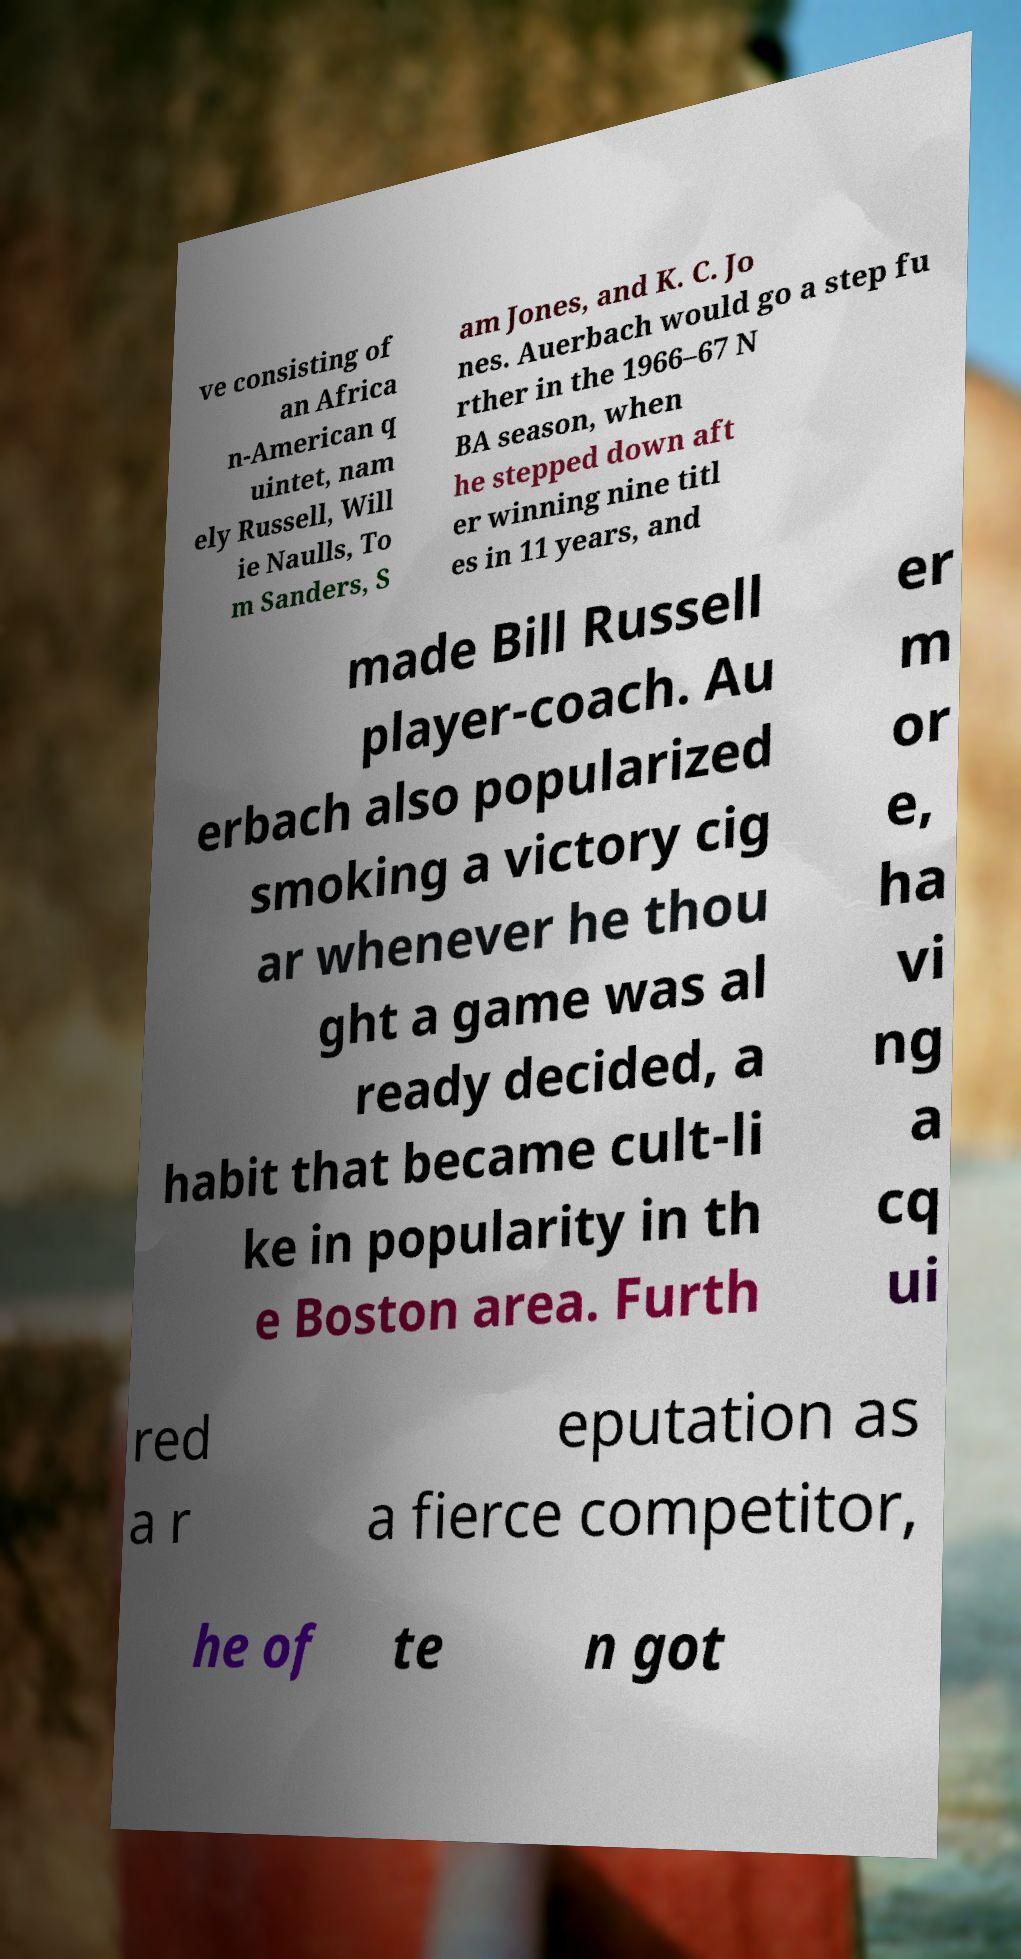For documentation purposes, I need the text within this image transcribed. Could you provide that? ve consisting of an Africa n-American q uintet, nam ely Russell, Will ie Naulls, To m Sanders, S am Jones, and K. C. Jo nes. Auerbach would go a step fu rther in the 1966–67 N BA season, when he stepped down aft er winning nine titl es in 11 years, and made Bill Russell player-coach. Au erbach also popularized smoking a victory cig ar whenever he thou ght a game was al ready decided, a habit that became cult-li ke in popularity in th e Boston area. Furth er m or e, ha vi ng a cq ui red a r eputation as a fierce competitor, he of te n got 